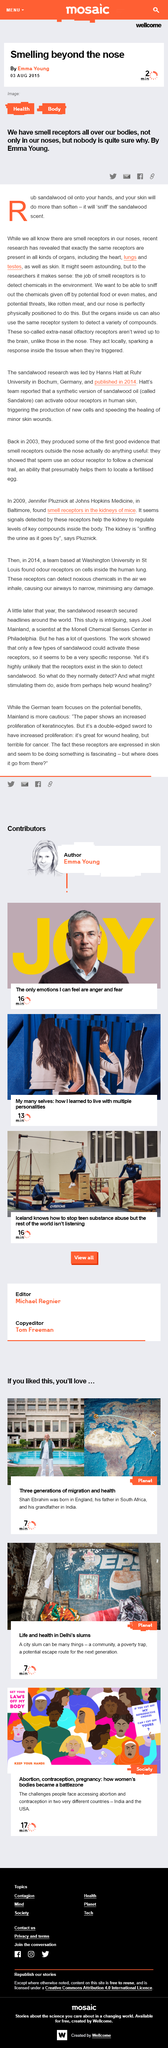Indicate a few pertinent items in this graphic. The article by Emma Young states that smell receptors are located in various parts of the body, including the nose, heart, lungs, testes, and skin. The receptor system in organs is known as the extra-nasal olfactory receptors. The job of smell receptors is to detect chemicals in the environment. 